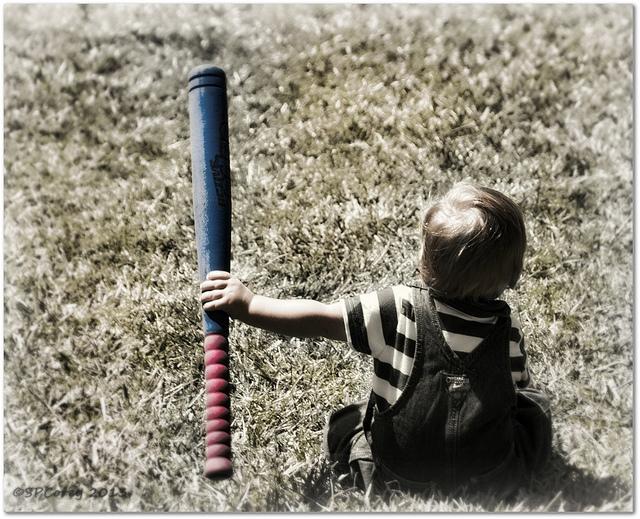What kind of shirt is the kids wearing?
Short answer required. Striped. What is he holding?
Concise answer only. Bat. How old is the kid?
Keep it brief. 2. 